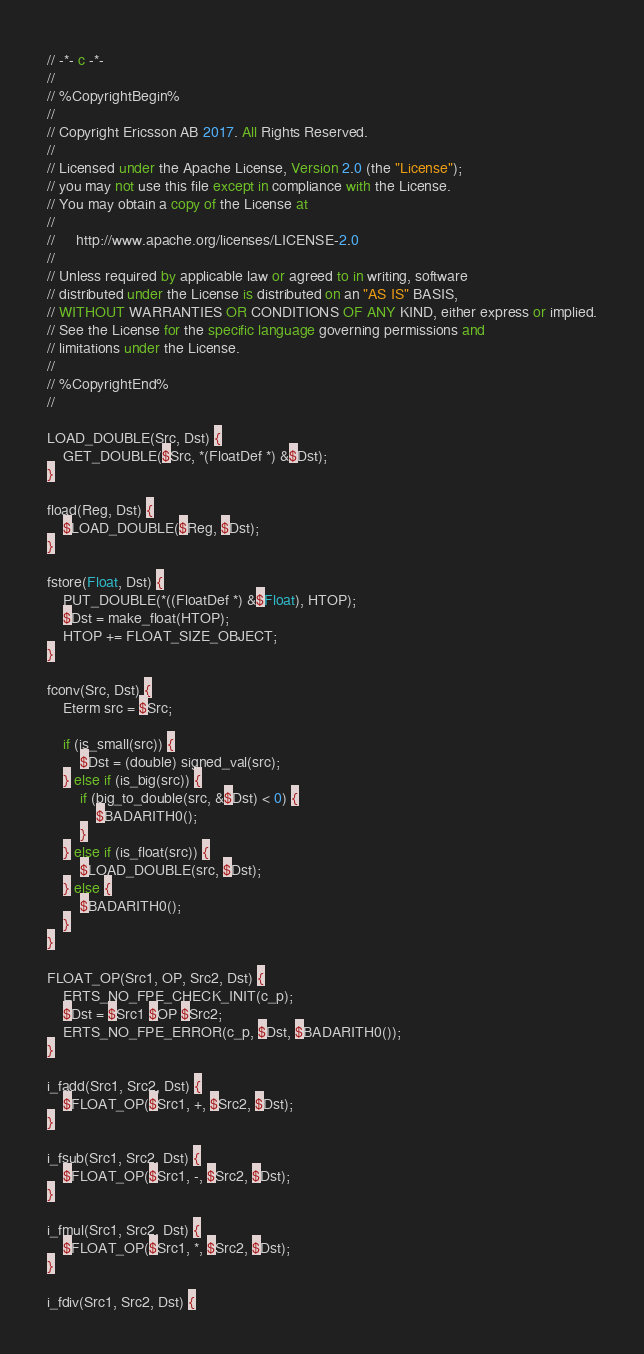Convert code to text. <code><loc_0><loc_0><loc_500><loc_500><_SQL_>// -*- c -*-
//
// %CopyrightBegin%
//
// Copyright Ericsson AB 2017. All Rights Reserved.
//
// Licensed under the Apache License, Version 2.0 (the "License");
// you may not use this file except in compliance with the License.
// You may obtain a copy of the License at
//
//     http://www.apache.org/licenses/LICENSE-2.0
//
// Unless required by applicable law or agreed to in writing, software
// distributed under the License is distributed on an "AS IS" BASIS,
// WITHOUT WARRANTIES OR CONDITIONS OF ANY KIND, either express or implied.
// See the License for the specific language governing permissions and
// limitations under the License.
//
// %CopyrightEnd%
//

LOAD_DOUBLE(Src, Dst) {
    GET_DOUBLE($Src, *(FloatDef *) &$Dst);
}

fload(Reg, Dst) {
    $LOAD_DOUBLE($Reg, $Dst);
}

fstore(Float, Dst) {
    PUT_DOUBLE(*((FloatDef *) &$Float), HTOP);
    $Dst = make_float(HTOP);
    HTOP += FLOAT_SIZE_OBJECT;
}

fconv(Src, Dst) {
    Eterm src = $Src;

    if (is_small(src)) {
        $Dst = (double) signed_val(src);
    } else if (is_big(src)) {
        if (big_to_double(src, &$Dst) < 0) {
            $BADARITH0();
        }
    } else if (is_float(src)) {
        $LOAD_DOUBLE(src, $Dst);
    } else {
        $BADARITH0();
    }
}

FLOAT_OP(Src1, OP, Src2, Dst) {
    ERTS_NO_FPE_CHECK_INIT(c_p);
    $Dst = $Src1 $OP $Src2;
    ERTS_NO_FPE_ERROR(c_p, $Dst, $BADARITH0());
}

i_fadd(Src1, Src2, Dst) {
    $FLOAT_OP($Src1, +, $Src2, $Dst);
}

i_fsub(Src1, Src2, Dst) {
    $FLOAT_OP($Src1, -, $Src2, $Dst);
}

i_fmul(Src1, Src2, Dst) {
    $FLOAT_OP($Src1, *, $Src2, $Dst);
}

i_fdiv(Src1, Src2, Dst) {</code> 